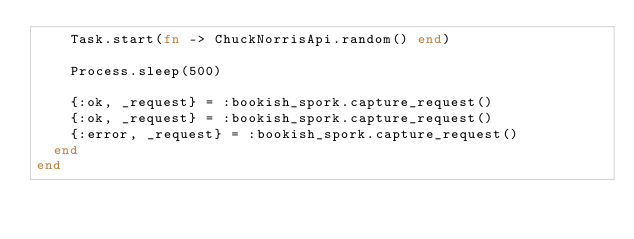Convert code to text. <code><loc_0><loc_0><loc_500><loc_500><_Elixir_>    Task.start(fn -> ChuckNorrisApi.random() end)

    Process.sleep(500)

    {:ok, _request} = :bookish_spork.capture_request()
    {:ok, _request} = :bookish_spork.capture_request()
    {:error, _request} = :bookish_spork.capture_request()
  end
end
</code> 